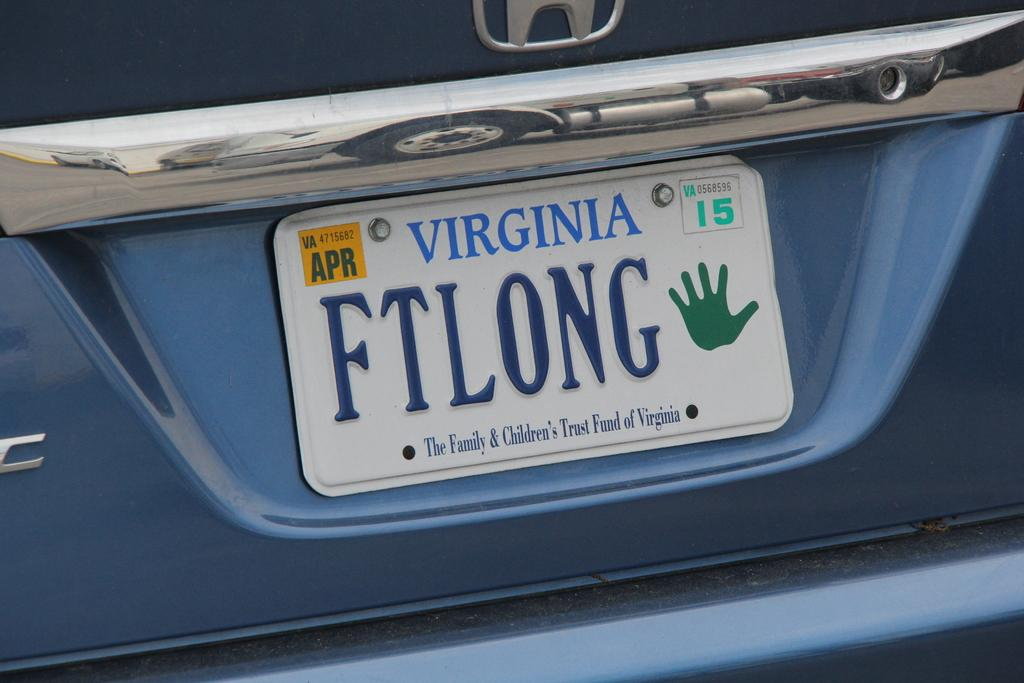<image>
Share a concise interpretation of the image provided. White Virginia license plate that says FTLONG on it. 